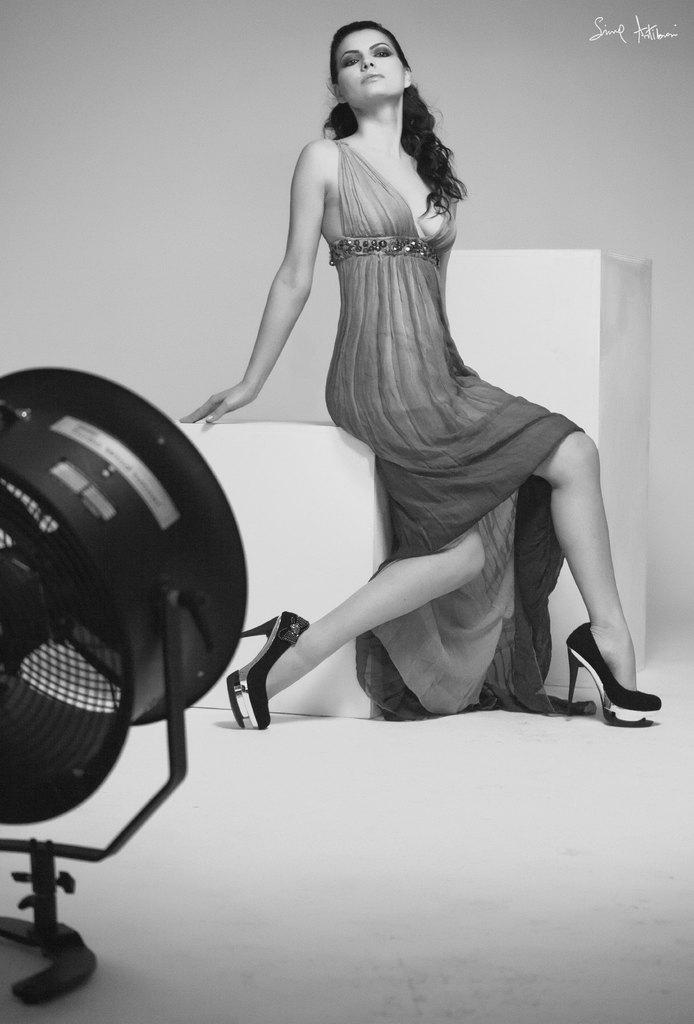What is the woman in the image doing? The woman is sitting in the image. What object is visible in the foreground of the image? There is a fan in the foreground of the image. Where is the text located in the image? The text is in the top right corner of the image. Can you describe the nature of the image? The image is an edited picture. What type of glove is the woman wearing in the image? There is no glove visible in the image; the woman is not wearing any gloves. 